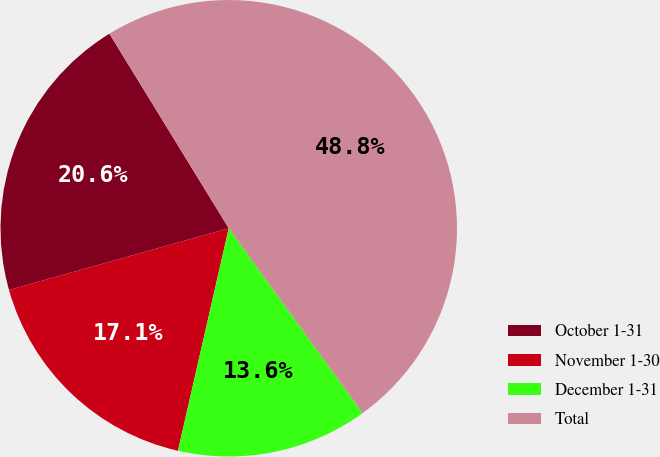<chart> <loc_0><loc_0><loc_500><loc_500><pie_chart><fcel>October 1-31<fcel>November 1-30<fcel>December 1-31<fcel>Total<nl><fcel>20.6%<fcel>17.07%<fcel>13.55%<fcel>48.78%<nl></chart> 